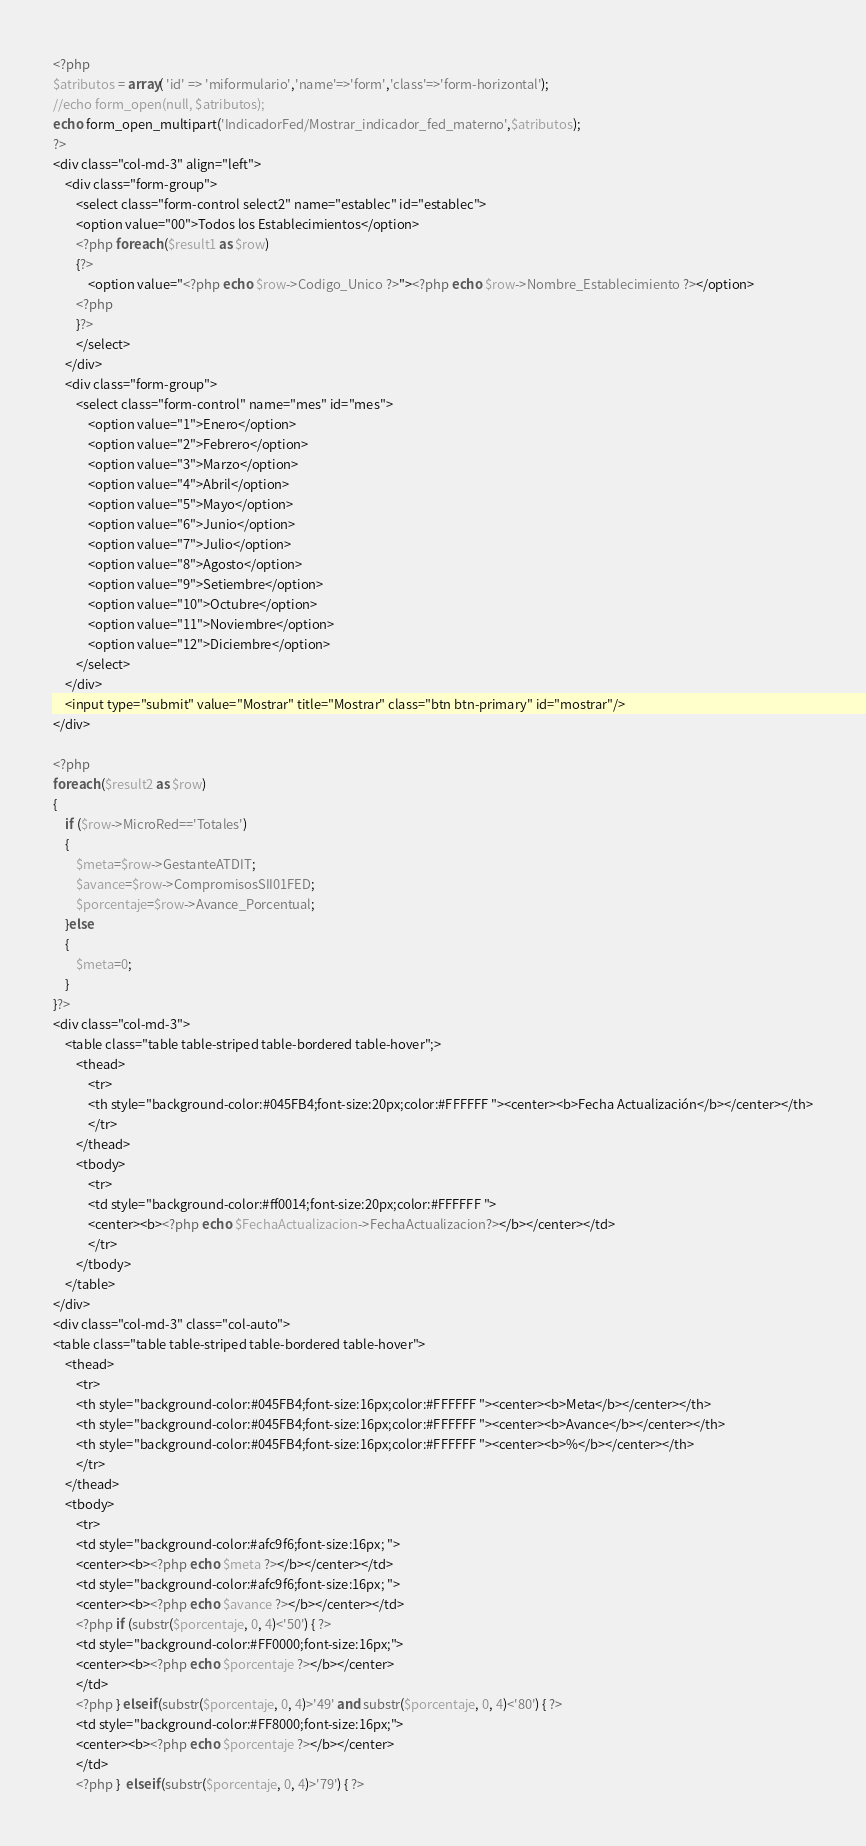<code> <loc_0><loc_0><loc_500><loc_500><_PHP_><?php
$atributos = array( 'id' => 'miformulario','name'=>'form','class'=>'form-horizontal');
//echo form_open(null, $atributos);
echo form_open_multipart('IndicadorFed/Mostrar_indicador_fed_materno',$atributos);
?>
<div class="col-md-3" align="left">
    <div class="form-group">
        <select class="form-control select2" name="establec" id="establec">
        <option value="00">Todos los Establecimientos</option>                    
        <?php foreach ($result1 as $row) 
        {?>
            <option value="<?php echo $row->Codigo_Unico ?>"><?php echo $row->Nombre_Establecimiento ?></option>
        <?php
        }?>
        </select>
    </div>
    <div class="form-group">
        <select class="form-control" name="mes" id="mes">
            <option value="1">Enero</option>
            <option value="2">Febrero</option>
            <option value="3">Marzo</option>
            <option value="4">Abril</option>
            <option value="5">Mayo</option>
            <option value="6">Junio</option>
            <option value="7">Julio</option>
            <option value="8">Agosto</option>
            <option value="9">Setiembre</option>
            <option value="10">Octubre</option>
            <option value="11">Noviembre</option>
            <option value="12">Diciembre</option>
        </select>
    </div>
    <input type="submit" value="Mostrar" title="Mostrar" class="btn btn-primary" id="mostrar"/>
</div>

<?php
foreach ($result2 as $row) 
{
    if ($row->MicroRed=='Totales') 
    {
        $meta=$row->GestanteATDIT;
        $avance=$row->CompromisosSII01FED;
        $porcentaje=$row->Avance_Porcentual;
    }else
    {
        $meta=0;
    }
}?>
<div class="col-md-3">
    <table class="table table-striped table-bordered table-hover";>
        <thead>
            <tr>
            <th style="background-color:#045FB4;font-size:20px;color:#FFFFFF "><center><b>Fecha Actualización</b></center></th>
            </tr>
        </thead>
        <tbody>
            <tr>
            <td style="background-color:#ff0014;font-size:20px;color:#FFFFFF ">
            <center><b><?php echo $FechaActualizacion->FechaActualizacion?></b></center></td>
            </tr>
        </tbody>
    </table>
</div>
<div class="col-md-3" class="col-auto">
<table class="table table-striped table-bordered table-hover">
    <thead>
        <tr>
        <th style="background-color:#045FB4;font-size:16px;color:#FFFFFF "><center><b>Meta</b></center></th>
        <th style="background-color:#045FB4;font-size:16px;color:#FFFFFF "><center><b>Avance</b></center></th>
        <th style="background-color:#045FB4;font-size:16px;color:#FFFFFF "><center><b>%</b></center></th>
        </tr>
    </thead>
    <tbody>
        <tr>
        <td style="background-color:#afc9f6;font-size:16px; ">
        <center><b><?php echo $meta ?></b></center></td>
        <td style="background-color:#afc9f6;font-size:16px; ">
        <center><b><?php echo $avance ?></b></center></td>
        <?php if (substr($porcentaje, 0, 4)<'50') { ?> 
        <td style="background-color:#FF0000;font-size:16px;">
        <center><b><?php echo $porcentaje ?></b></center>
        </td>
        <?php } elseif (substr($porcentaje, 0, 4)>'49' and substr($porcentaje, 0, 4)<'80') { ?> 
        <td style="background-color:#FF8000;font-size:16px;">
        <center><b><?php echo $porcentaje ?></b></center>
        </td>
        <?php }  elseif (substr($porcentaje, 0, 4)>'79') { ?></code> 